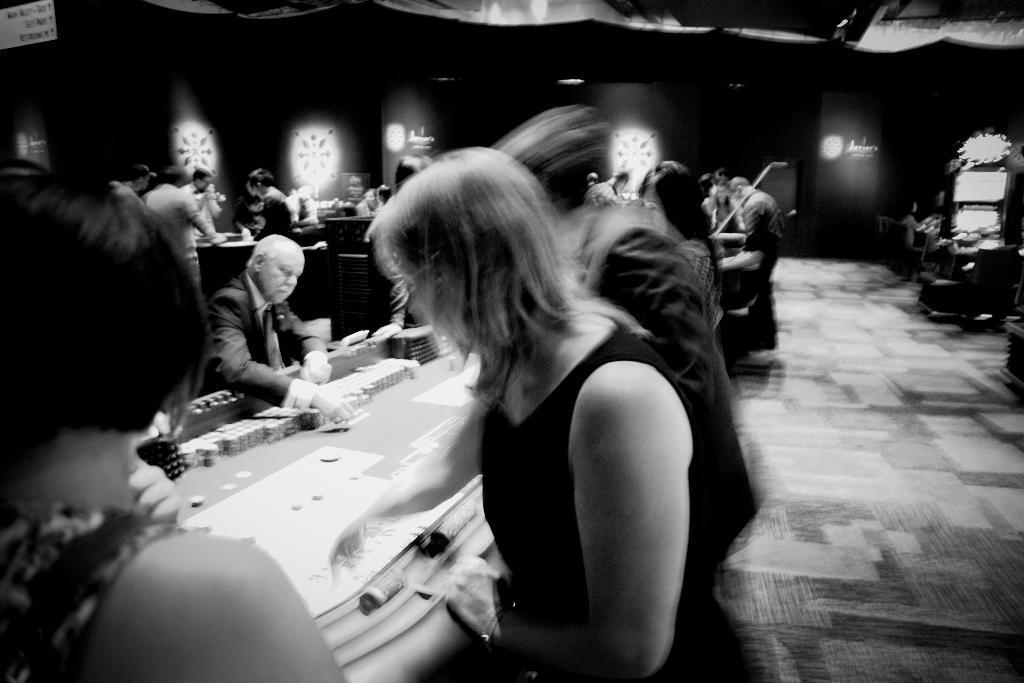Please provide a concise description of this image. This is a black and white image as we can see there are some persons playing in a casino. 